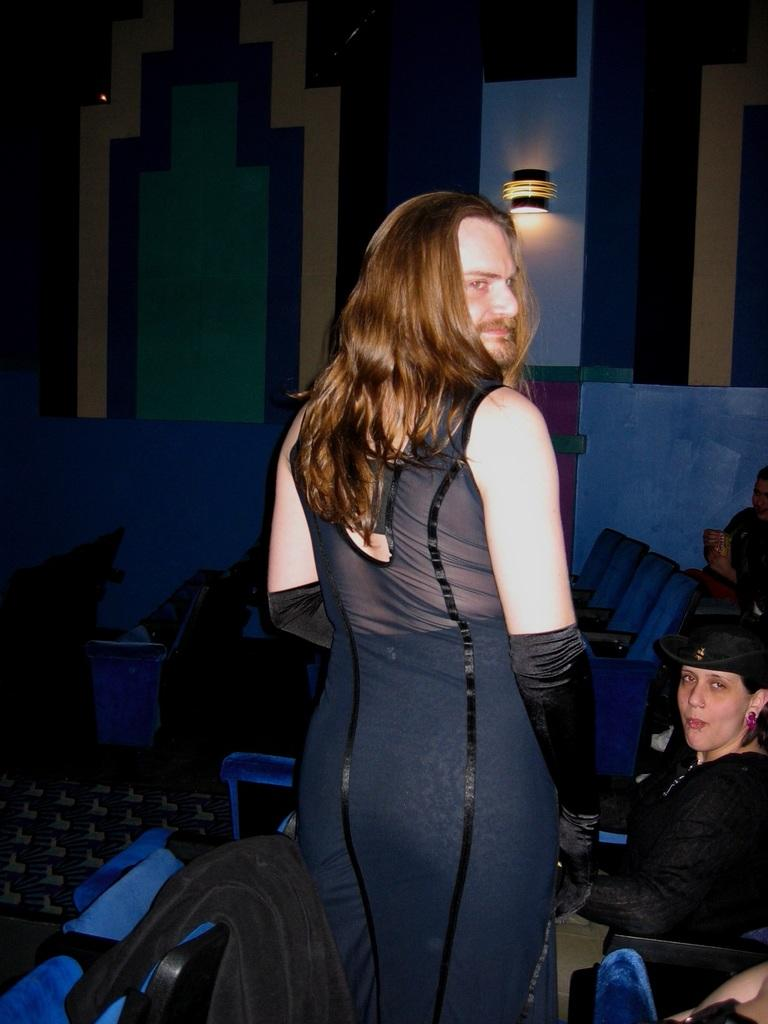What is the main subject of the image? There is a person standing in the center of the image. What is the person standing on? The person is standing on the floor. What can be seen in the background of the image? There are persons, chairs, a light, and a wall in the background of the image. What type of mark is the person making on the wall in the image? There is no mark being made on the wall in the image; the person is simply standing in the center. What is the argument about in the image? There is no argument depicted in the image; it shows a person standing in the center and other elements in the background. 